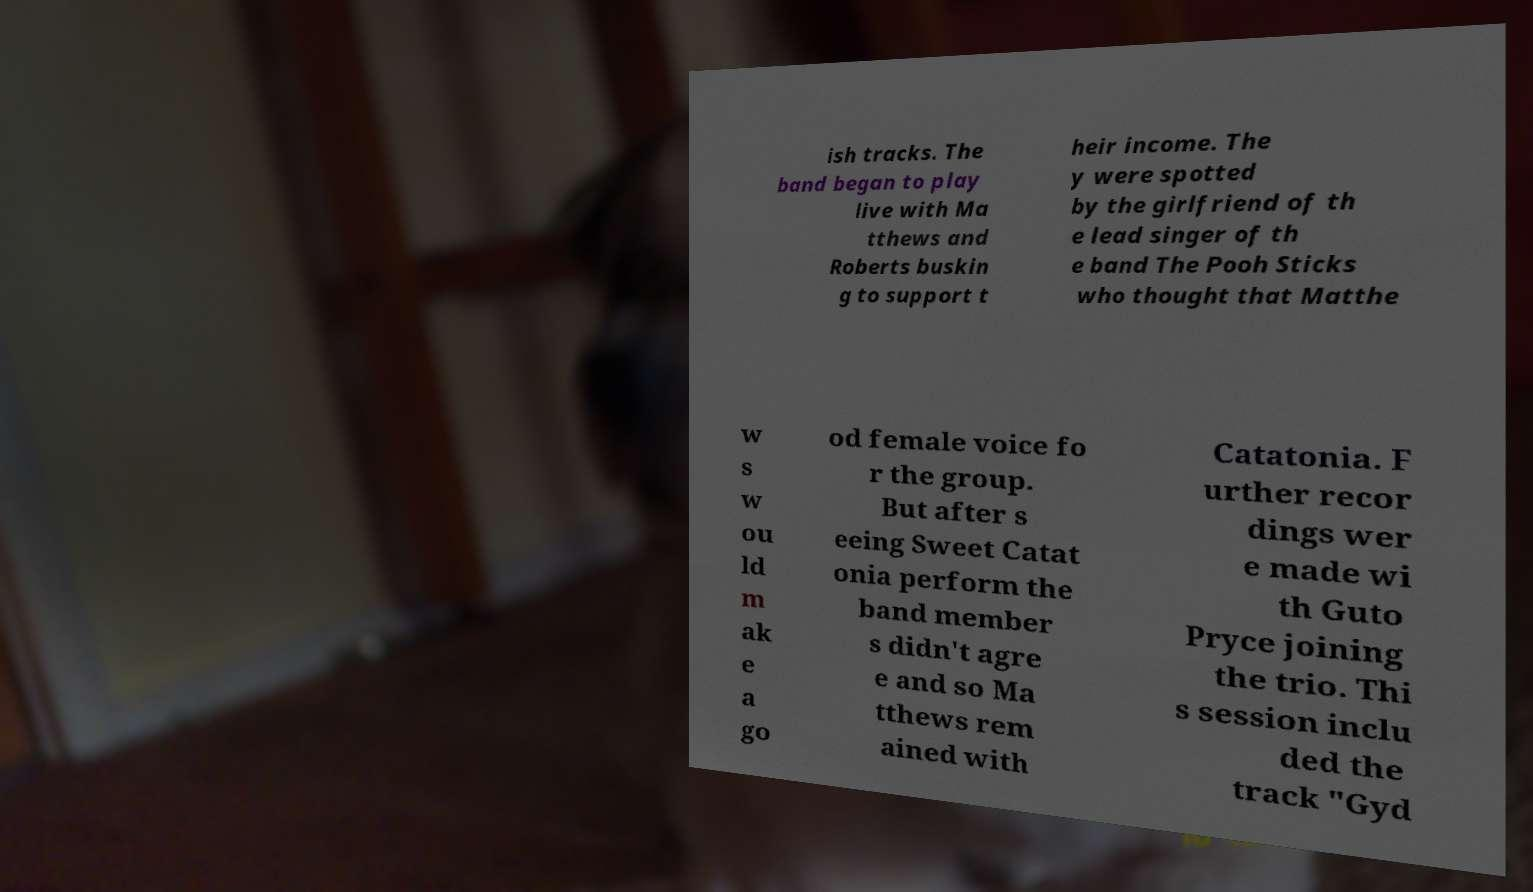Can you accurately transcribe the text from the provided image for me? ish tracks. The band began to play live with Ma tthews and Roberts buskin g to support t heir income. The y were spotted by the girlfriend of th e lead singer of th e band The Pooh Sticks who thought that Matthe w s w ou ld m ak e a go od female voice fo r the group. But after s eeing Sweet Catat onia perform the band member s didn't agre e and so Ma tthews rem ained with Catatonia. F urther recor dings wer e made wi th Guto Pryce joining the trio. Thi s session inclu ded the track "Gyd 